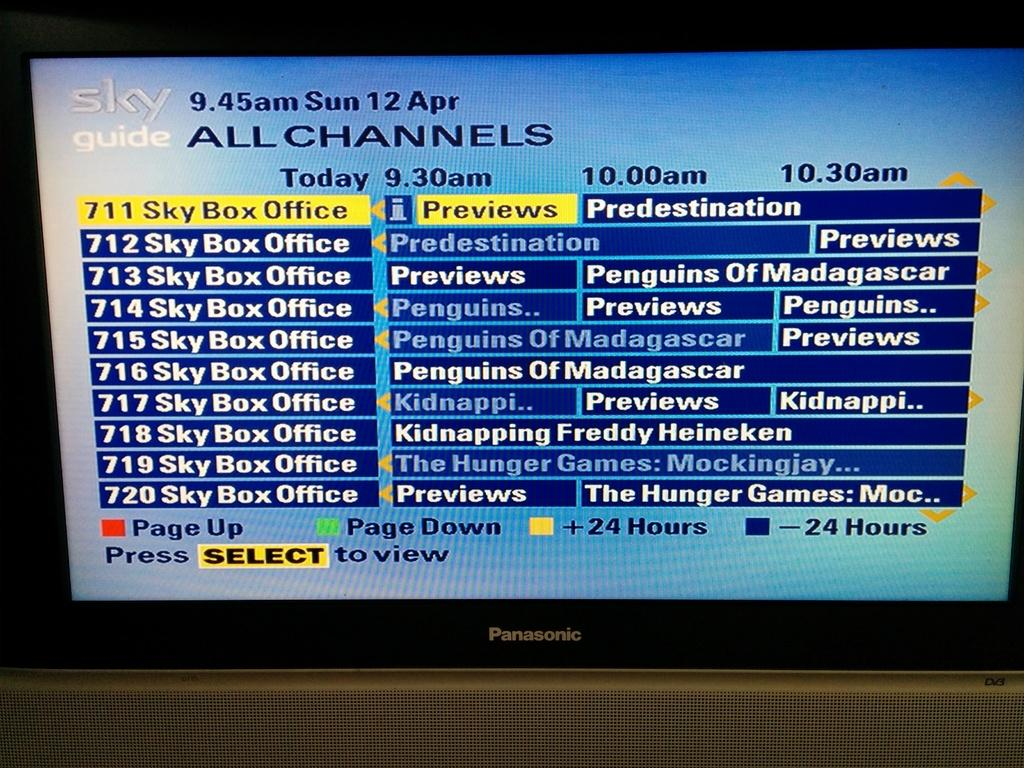<image>
Write a terse but informative summary of the picture. A TV showing the Sky News channel guide 